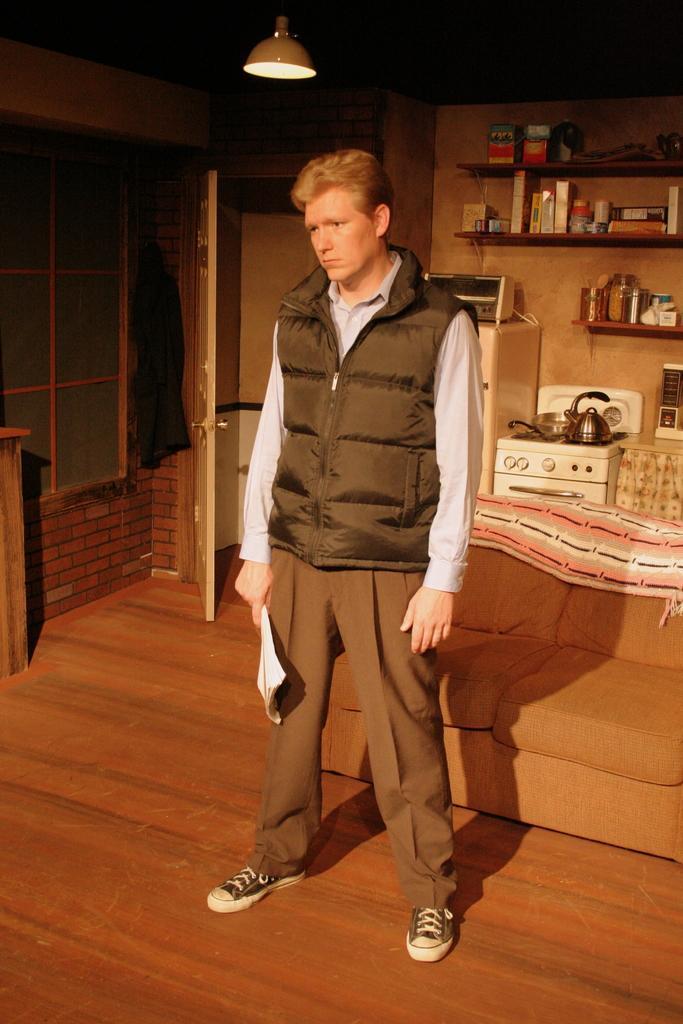Can you describe this image briefly? In this picture we can see a man is standing and holding a book, on the right side there is a sofa, in the background we can see a wall and shelves, there is a stove, a kettle and an oven in the middle, there are some bottles, boxes and other things present on these shelves, there is a light at the top of the picture, on the left side there is a cloth. 